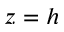<formula> <loc_0><loc_0><loc_500><loc_500>z = h</formula> 